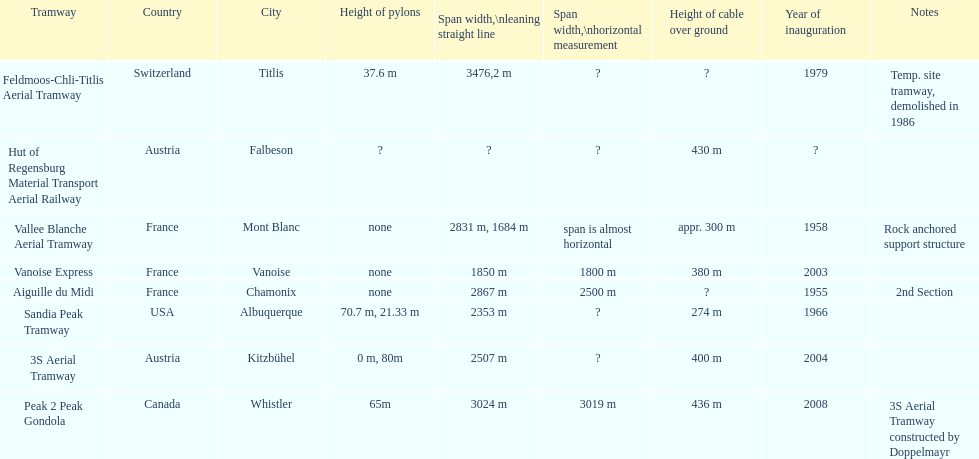Which tramway was inaugurated first, the 3s aerial tramway or the aiguille du midi? Aiguille du Midi. 